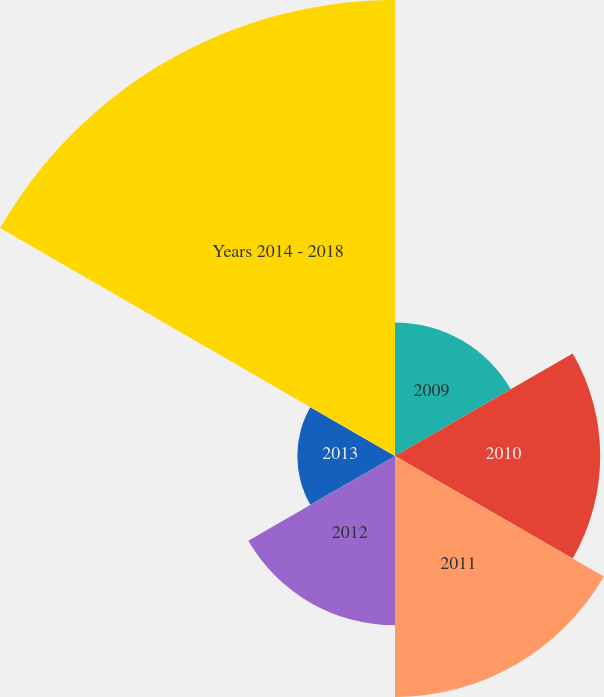<chart> <loc_0><loc_0><loc_500><loc_500><pie_chart><fcel>2009<fcel>2010<fcel>2011<fcel>2012<fcel>2013<fcel>Years 2014 - 2018<nl><fcel>10.25%<fcel>15.75%<fcel>18.5%<fcel>13.0%<fcel>7.5%<fcel>35.0%<nl></chart> 